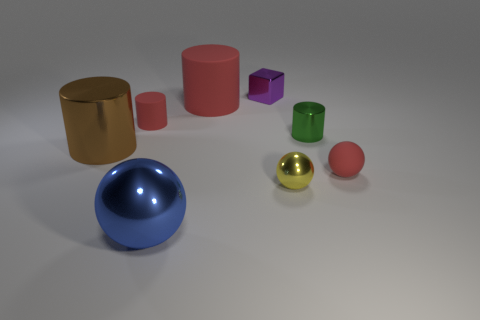Add 1 big brown matte cubes. How many objects exist? 9 Subtract all blocks. How many objects are left? 7 Add 5 tiny gray metallic cylinders. How many tiny gray metallic cylinders exist? 5 Subtract 1 brown cylinders. How many objects are left? 7 Subtract all yellow metal balls. Subtract all big red rubber cylinders. How many objects are left? 6 Add 4 tiny green metallic cylinders. How many tiny green metallic cylinders are left? 5 